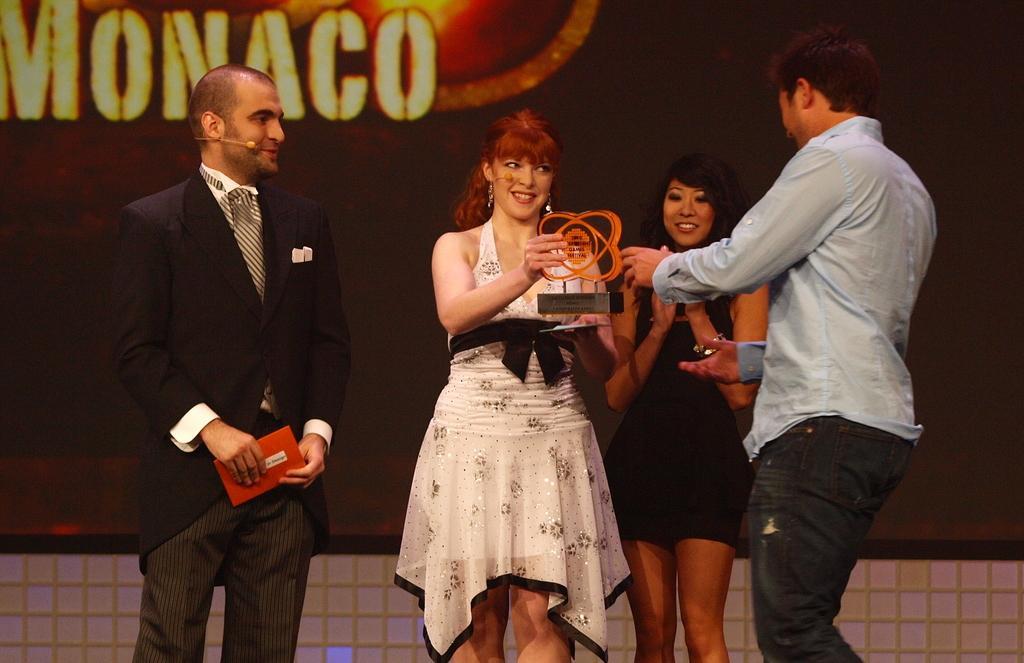Could you give a brief overview of what you see in this image? In this image in the center there are persons standing and smiling. On the left side there is a man standing and holding a paper in his hand. In the center there is a woman standing and holding award. In the background on the screen there is some text written on it. 